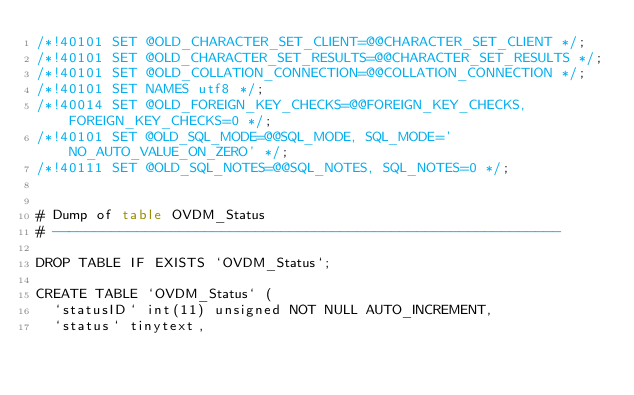<code> <loc_0><loc_0><loc_500><loc_500><_SQL_>/*!40101 SET @OLD_CHARACTER_SET_CLIENT=@@CHARACTER_SET_CLIENT */;
/*!40101 SET @OLD_CHARACTER_SET_RESULTS=@@CHARACTER_SET_RESULTS */;
/*!40101 SET @OLD_COLLATION_CONNECTION=@@COLLATION_CONNECTION */;
/*!40101 SET NAMES utf8 */;
/*!40014 SET @OLD_FOREIGN_KEY_CHECKS=@@FOREIGN_KEY_CHECKS, FOREIGN_KEY_CHECKS=0 */;
/*!40101 SET @OLD_SQL_MODE=@@SQL_MODE, SQL_MODE='NO_AUTO_VALUE_ON_ZERO' */;
/*!40111 SET @OLD_SQL_NOTES=@@SQL_NOTES, SQL_NOTES=0 */;


# Dump of table OVDM_Status
# ------------------------------------------------------------

DROP TABLE IF EXISTS `OVDM_Status`;

CREATE TABLE `OVDM_Status` (
  `statusID` int(11) unsigned NOT NULL AUTO_INCREMENT,
  `status` tinytext,</code> 